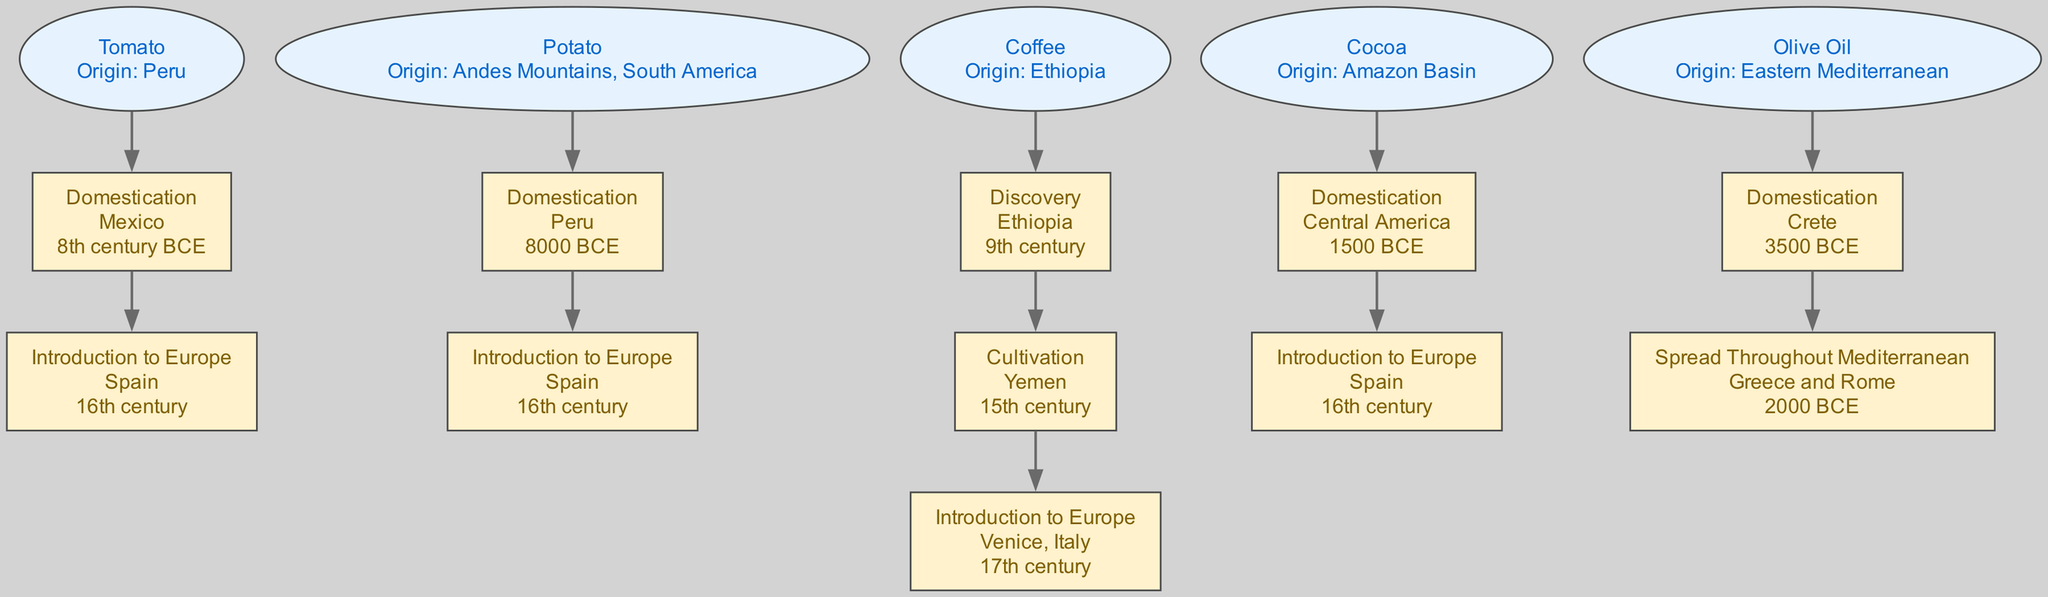What is the origin of Cocoa? The diagram shows that Cocoa originates from the Amazon Basin. This information is specifically stated under the Cocoa ingredient node.
Answer: Amazon Basin How many historical events are listed for Tomato? The diagram indicates two historical events connected to the Tomato ingredient node: "Domestication" and "Introduction to Europe". Therefore, there are two events.
Answer: 2 What event marks the introduction of Coffee to Europe? According to the diagram, the event that signifies the introduction of Coffee to Europe is labeled "Introduction to Europe," with the location specified as Venice, Italy.
Answer: Introduction to Europe Which ingredient has the earliest domestication date? The diagram indicates that the Potato was domesticated in 8000 BCE, the earliest date mentioned. Therefore, Potato has the earliest domestication date among the listed ingredients.
Answer: Potato In which century did Cocoa make its introduction to Europe? The diagram clearly states that Cocoa was introduced to Europe in the 16th century. This information can be found directly under the history of Cocoa.
Answer: 16th century Which ingredient was first cultivated in Yemen? The diagram shows that Coffee was the ingredient first cultivated in Yemen, as indicated in its history.
Answer: Coffee How many ingredients have an origin in South America? Evaluating the diagram, both the Potato (Andes Mountains, South America) and the Tomato (Peru) have origins in South America, indicating there are two ingredients with this origin.
Answer: 2 What is the period for the domestication of Olive Oil? The diagram states that the domestication of Olive Oil occurred in 3500 BCE, which is specified in its history section.
Answer: 3500 BCE 